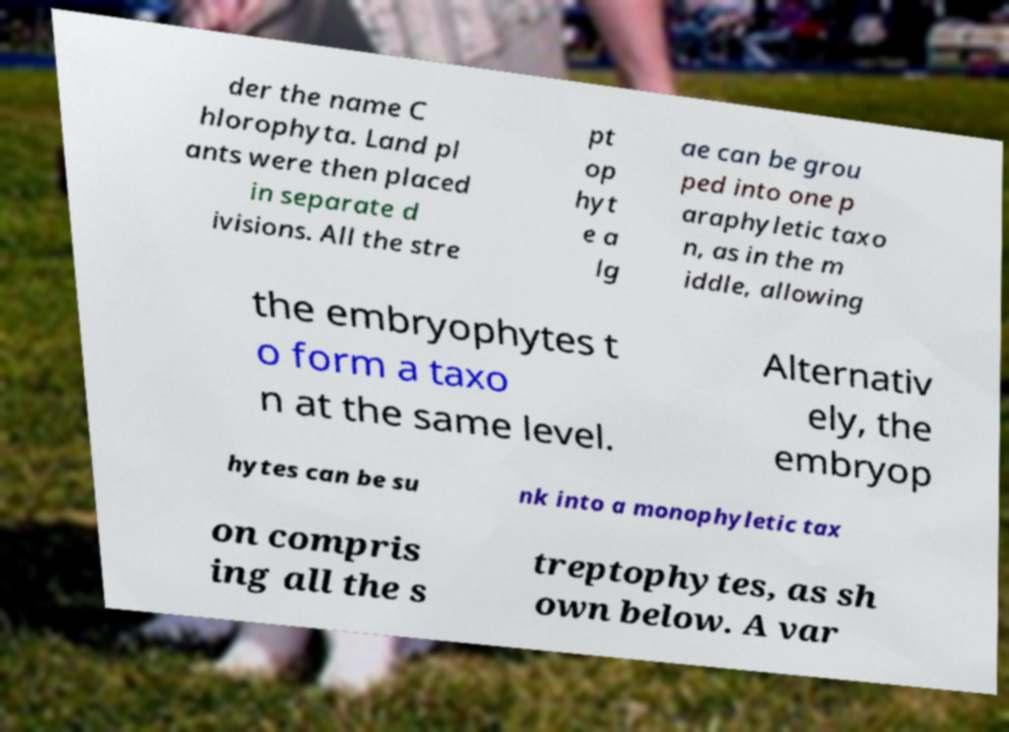What messages or text are displayed in this image? I need them in a readable, typed format. der the name C hlorophyta. Land pl ants were then placed in separate d ivisions. All the stre pt op hyt e a lg ae can be grou ped into one p araphyletic taxo n, as in the m iddle, allowing the embryophytes t o form a taxo n at the same level. Alternativ ely, the embryop hytes can be su nk into a monophyletic tax on compris ing all the s treptophytes, as sh own below. A var 